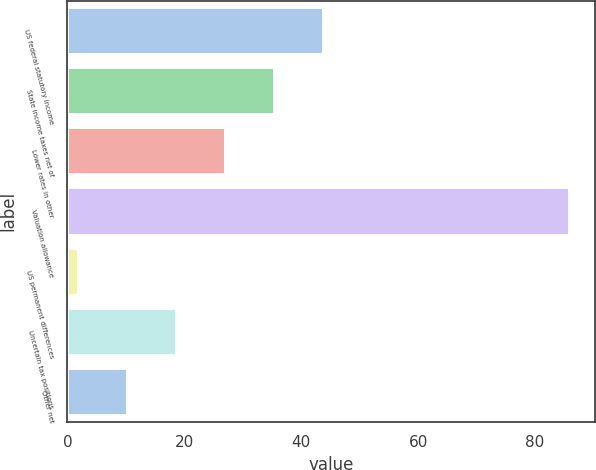Convert chart to OTSL. <chart><loc_0><loc_0><loc_500><loc_500><bar_chart><fcel>US federal statutory income<fcel>State income taxes net of<fcel>Lower rates in other<fcel>Valuation allowance<fcel>US permanent differences<fcel>Uncertain tax positions<fcel>Other net<nl><fcel>43.9<fcel>35.5<fcel>27.1<fcel>85.9<fcel>1.9<fcel>18.7<fcel>10.3<nl></chart> 